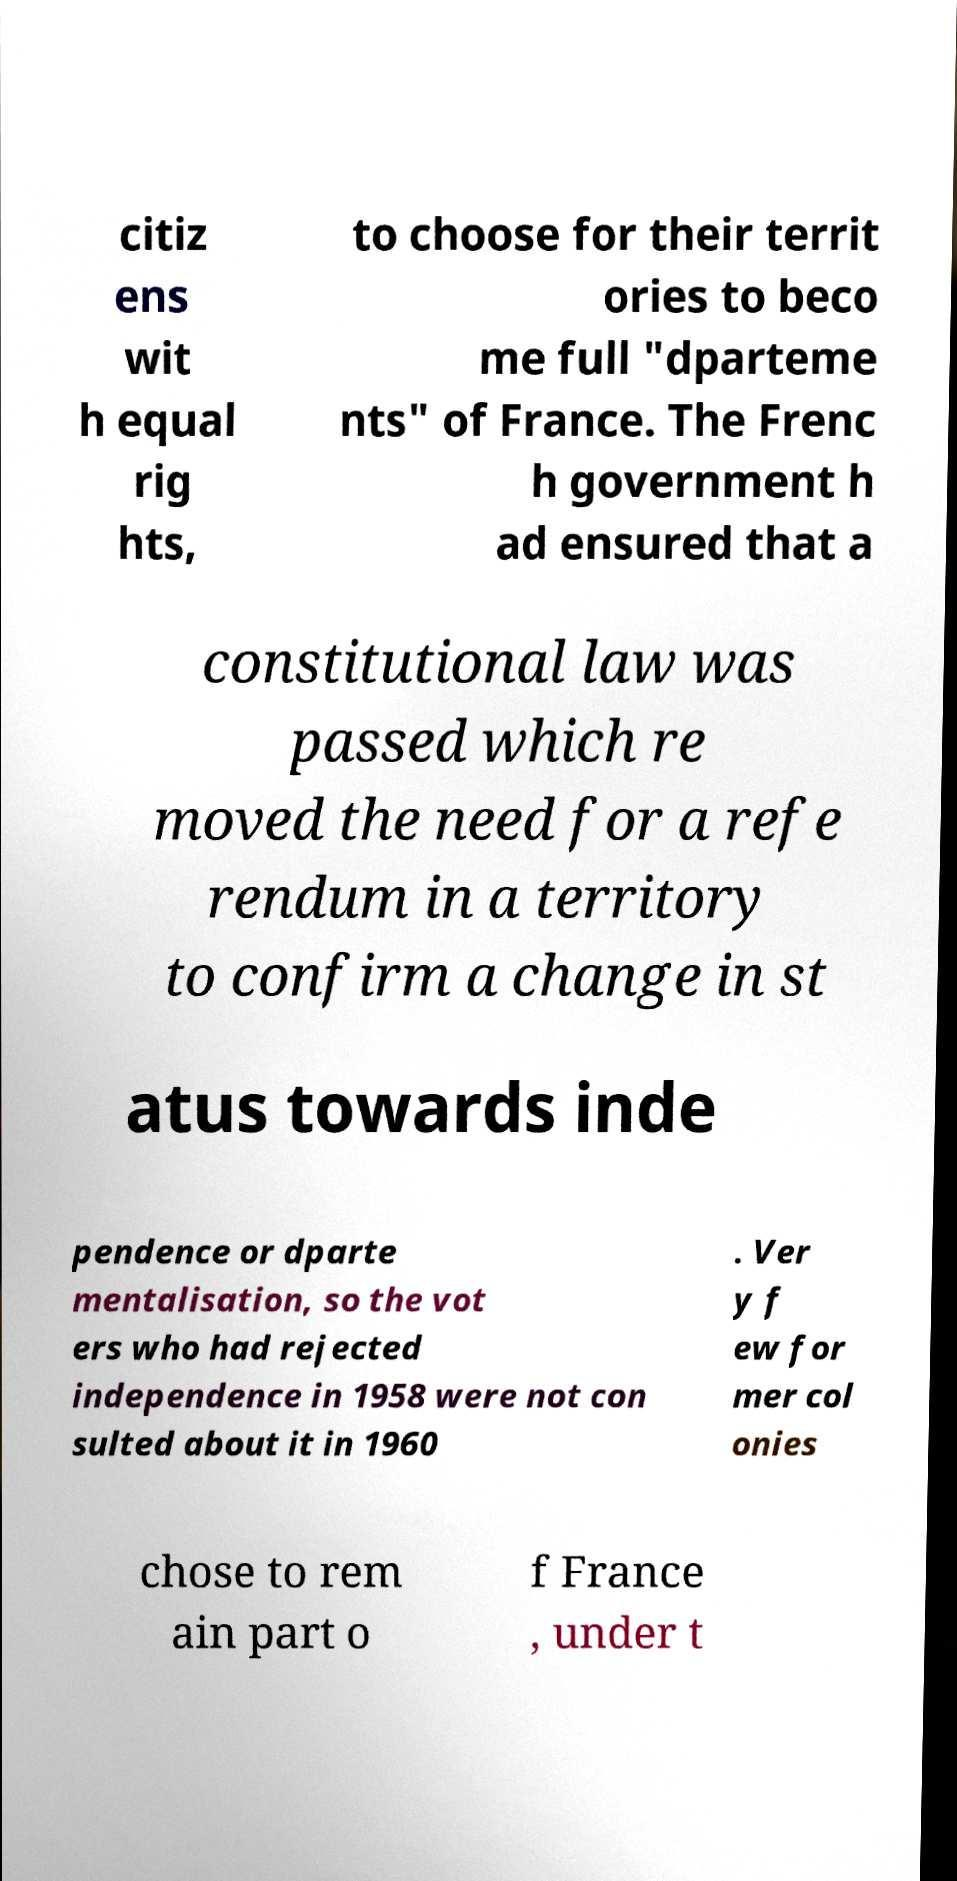I need the written content from this picture converted into text. Can you do that? citiz ens wit h equal rig hts, to choose for their territ ories to beco me full "dparteme nts" of France. The Frenc h government h ad ensured that a constitutional law was passed which re moved the need for a refe rendum in a territory to confirm a change in st atus towards inde pendence or dparte mentalisation, so the vot ers who had rejected independence in 1958 were not con sulted about it in 1960 . Ver y f ew for mer col onies chose to rem ain part o f France , under t 